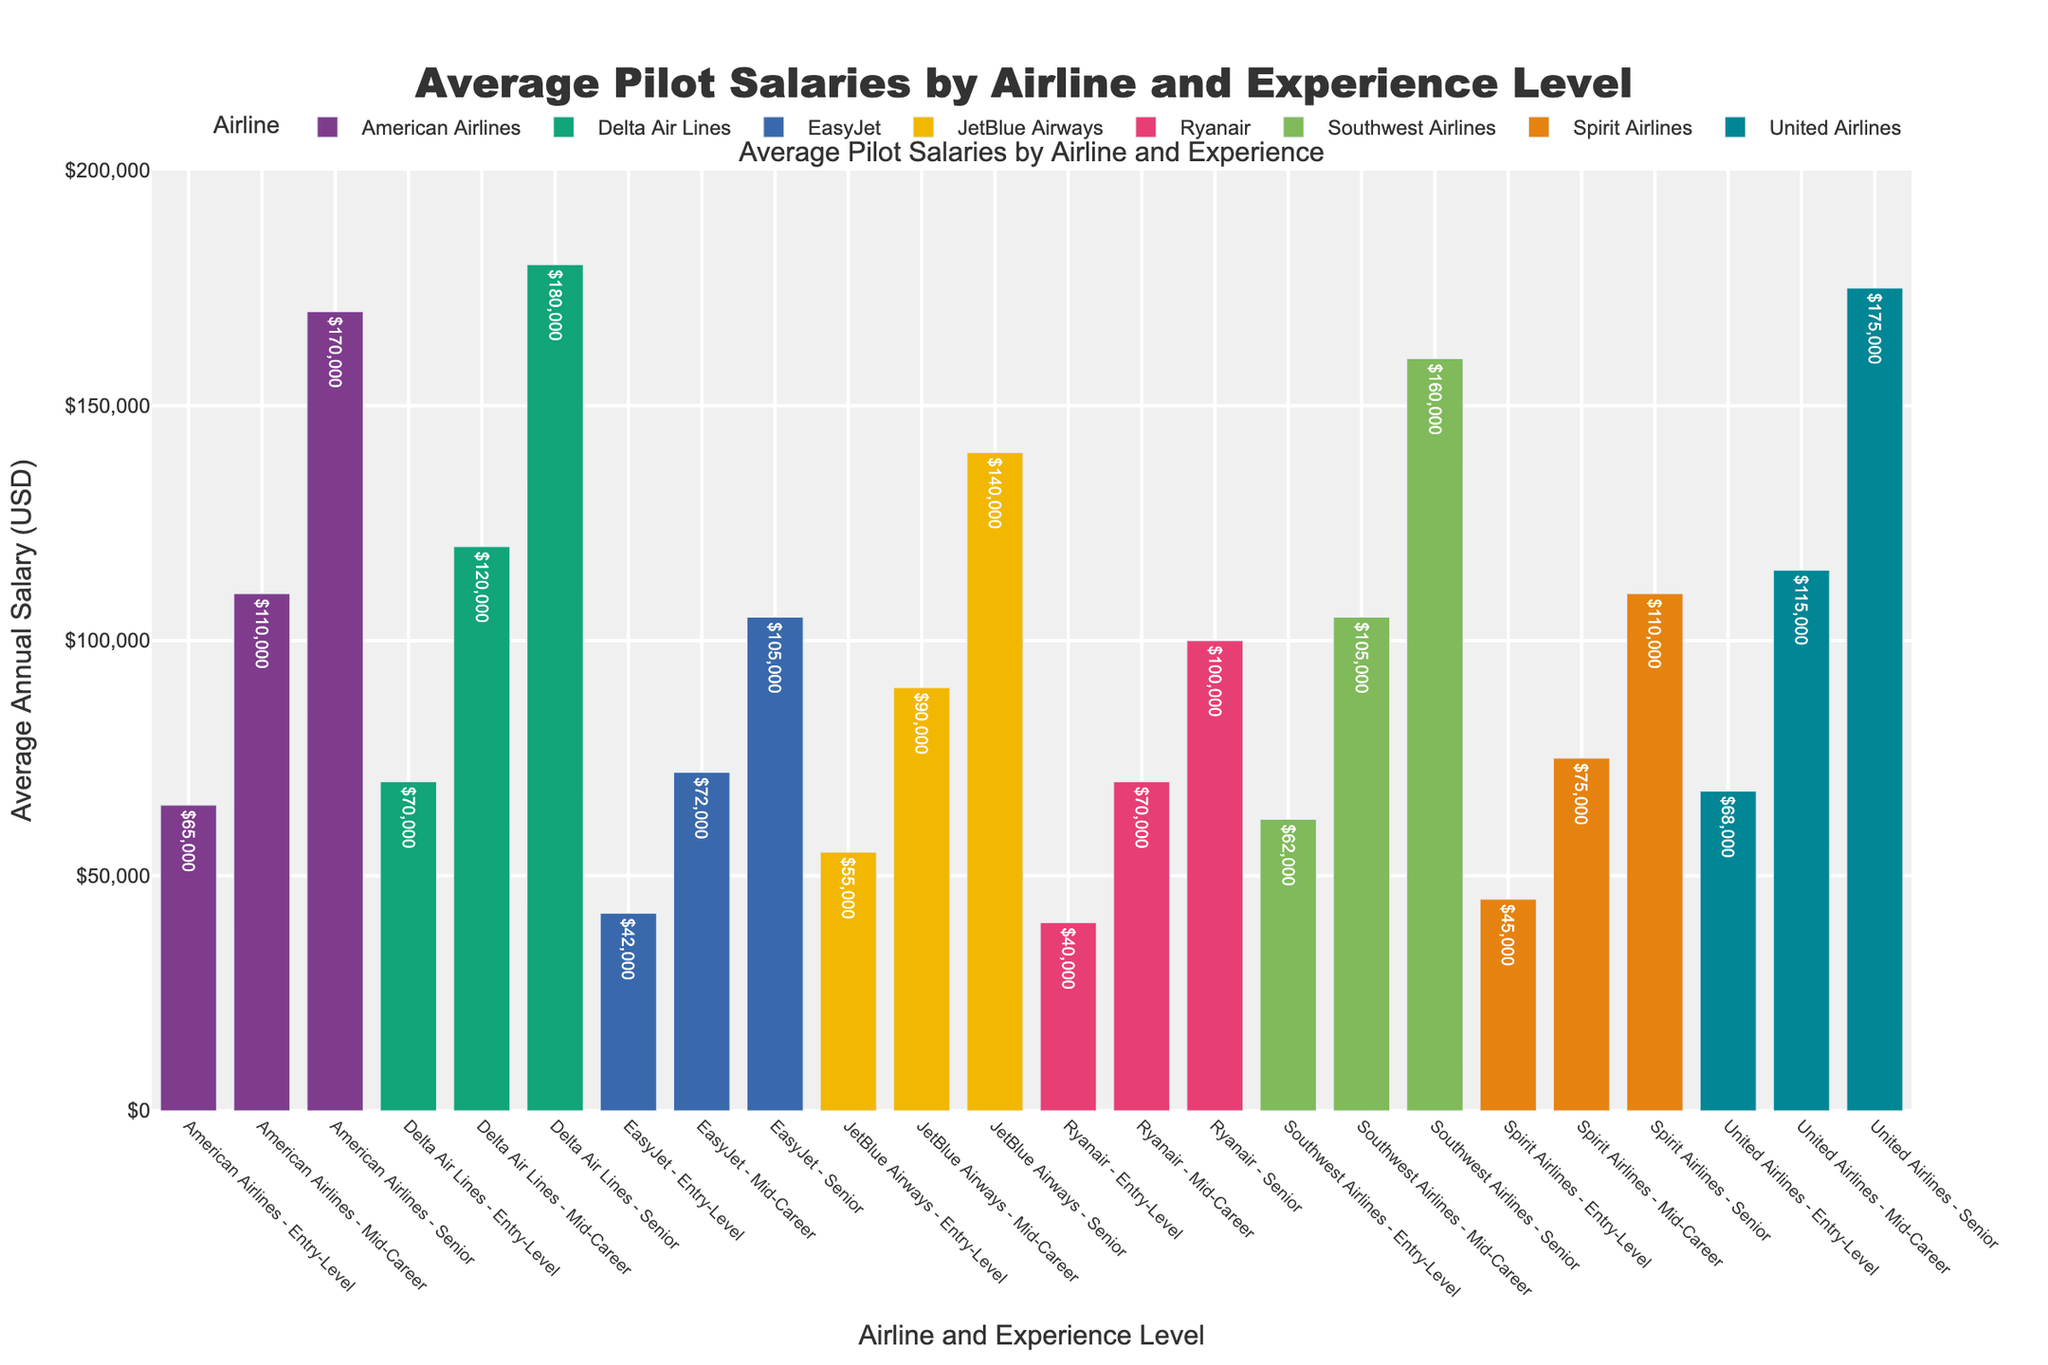What is the average annual salary for a senior pilot at Delta Air Lines? The bar representing the senior experience level at Delta Air Lines shows an annual salary of $180,000.
Answer: $180,000 Which airline provides the highest entry-level salary? By comparing the heights of the bars for entry-level salaries across all airlines, Delta Air Lines offers the highest entry-level salary with $70,000.
Answer: Delta Air Lines How much more does a senior pilot at United Airlines earn compared to a mid-career pilot at JetBlue Airways? The senior pilot salary at United Airlines is $175,000, and the mid-career pilot salary at JetBlue Airways is $90,000. The difference is $175,000 - $90,000 = $85,000.
Answer: $85,000 What is the difference in average annual salary between entry-level and senior pilots at American Airlines? The entry-level salary at American Airlines is $65,000, and the senior salary is $170,000. The difference is $170,000 - $65,000 = $105,000.
Answer: $105,000 Which airline has the smallest gap between entry-level and senior pilot salaries? By comparing the differences between entry-level and senior pilot salaries for each airline, Spirit Airlines has the smallest gap (senior $110,000 - entry-level $45,000 = $65,000).
Answer: Spirit Airlines How does the salary of a mid-career pilot at Ryanair compare to that of an entry-level pilot at Delta Air Lines? The mid-career salary at Ryanair is $70,000, which is equal to the entry-level salary at Delta Air Lines of $70,000.
Answer: equal What is the combined annual salary of a senior pilot at Southwest Airlines and an entry-level pilot at Spirit Airlines? The senior pilot salary at Southwest Airlines is $160,000 and the entry-level pilot salary at Spirit Airlines is $45,000. The combined salary is $160,000 + $45,000 = $205,000.
Answer: $205,000 Which airline has the lowest senior pilot salary, and what is it? Examining the lowest point on the bar chart for senior pilots shows that Ryanair has the lowest senior pilot salary, which is $100,000.
Answer: Ryanair, $100,000 Do Southwest Airlines mid-career pilots make more than American Airlines entry-level pilots? The bar representing mid-career pilots at Southwest Airlines shows a salary of $105,000, while the entry-level pilot salary at American Airlines is $65,000. So, yes, they do make more.
Answer: Yes 